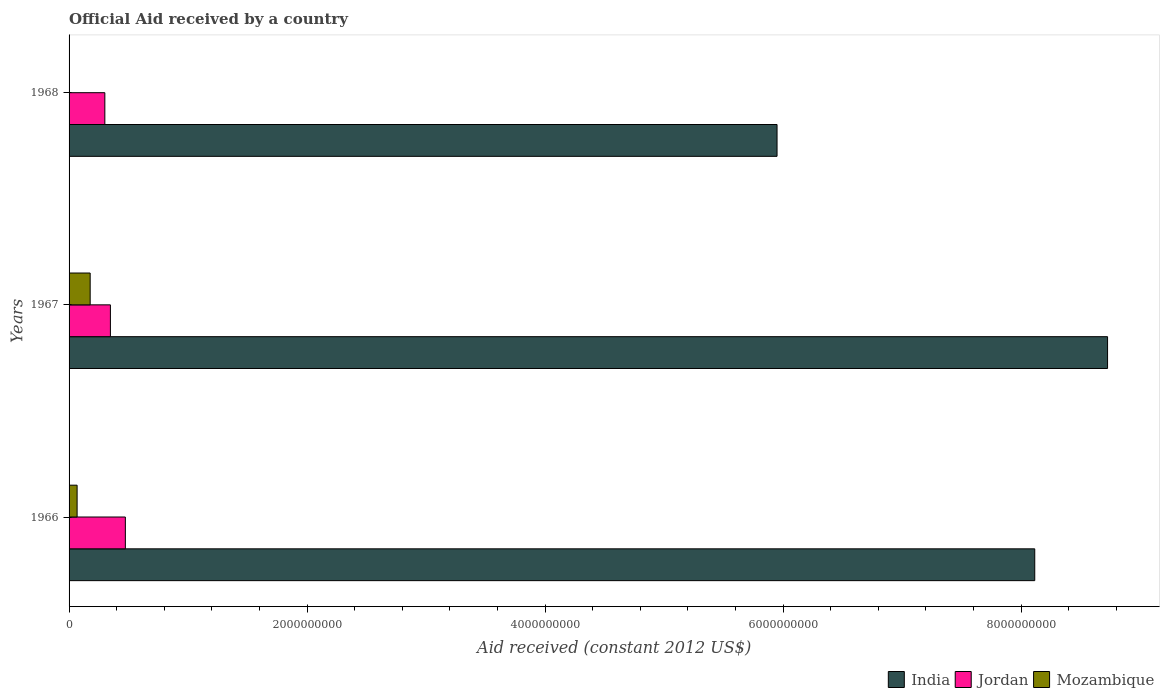What is the label of the 1st group of bars from the top?
Offer a terse response. 1968. What is the net official aid received in India in 1967?
Provide a short and direct response. 8.73e+09. Across all years, what is the maximum net official aid received in India?
Give a very brief answer. 8.73e+09. Across all years, what is the minimum net official aid received in India?
Provide a succinct answer. 5.95e+09. In which year was the net official aid received in India maximum?
Give a very brief answer. 1967. In which year was the net official aid received in Jordan minimum?
Make the answer very short. 1968. What is the total net official aid received in Mozambique in the graph?
Provide a succinct answer. 2.45e+08. What is the difference between the net official aid received in Jordan in 1967 and that in 1968?
Your response must be concise. 4.67e+07. What is the difference between the net official aid received in India in 1967 and the net official aid received in Mozambique in 1968?
Offer a terse response. 8.73e+09. What is the average net official aid received in India per year?
Ensure brevity in your answer.  7.60e+09. In the year 1966, what is the difference between the net official aid received in India and net official aid received in Mozambique?
Provide a succinct answer. 8.05e+09. In how many years, is the net official aid received in Jordan greater than 7200000000 US$?
Your answer should be very brief. 0. What is the ratio of the net official aid received in Mozambique in 1966 to that in 1968?
Your answer should be compact. 375. Is the difference between the net official aid received in India in 1966 and 1968 greater than the difference between the net official aid received in Mozambique in 1966 and 1968?
Your answer should be very brief. Yes. What is the difference between the highest and the second highest net official aid received in Mozambique?
Your response must be concise. 1.10e+08. What is the difference between the highest and the lowest net official aid received in Mozambique?
Keep it short and to the point. 1.77e+08. In how many years, is the net official aid received in Mozambique greater than the average net official aid received in Mozambique taken over all years?
Your answer should be compact. 1. What does the 3rd bar from the top in 1967 represents?
Your answer should be very brief. India. What does the 3rd bar from the bottom in 1966 represents?
Provide a short and direct response. Mozambique. Is it the case that in every year, the sum of the net official aid received in Mozambique and net official aid received in Jordan is greater than the net official aid received in India?
Your response must be concise. No. How many bars are there?
Make the answer very short. 9. Are all the bars in the graph horizontal?
Ensure brevity in your answer.  Yes. How many years are there in the graph?
Make the answer very short. 3. Are the values on the major ticks of X-axis written in scientific E-notation?
Your answer should be very brief. No. Does the graph contain any zero values?
Offer a very short reply. No. Does the graph contain grids?
Make the answer very short. No. Where does the legend appear in the graph?
Offer a very short reply. Bottom right. What is the title of the graph?
Your response must be concise. Official Aid received by a country. Does "Brunei Darussalam" appear as one of the legend labels in the graph?
Offer a terse response. No. What is the label or title of the X-axis?
Provide a short and direct response. Aid received (constant 2012 US$). What is the label or title of the Y-axis?
Keep it short and to the point. Years. What is the Aid received (constant 2012 US$) of India in 1966?
Provide a succinct answer. 8.11e+09. What is the Aid received (constant 2012 US$) of Jordan in 1966?
Provide a succinct answer. 4.73e+08. What is the Aid received (constant 2012 US$) in Mozambique in 1966?
Your answer should be compact. 6.75e+07. What is the Aid received (constant 2012 US$) of India in 1967?
Keep it short and to the point. 8.73e+09. What is the Aid received (constant 2012 US$) of Jordan in 1967?
Your answer should be very brief. 3.47e+08. What is the Aid received (constant 2012 US$) of Mozambique in 1967?
Give a very brief answer. 1.77e+08. What is the Aid received (constant 2012 US$) in India in 1968?
Provide a succinct answer. 5.95e+09. What is the Aid received (constant 2012 US$) in Jordan in 1968?
Your answer should be compact. 3.01e+08. Across all years, what is the maximum Aid received (constant 2012 US$) of India?
Give a very brief answer. 8.73e+09. Across all years, what is the maximum Aid received (constant 2012 US$) of Jordan?
Offer a terse response. 4.73e+08. Across all years, what is the maximum Aid received (constant 2012 US$) in Mozambique?
Your answer should be compact. 1.77e+08. Across all years, what is the minimum Aid received (constant 2012 US$) of India?
Offer a very short reply. 5.95e+09. Across all years, what is the minimum Aid received (constant 2012 US$) of Jordan?
Your response must be concise. 3.01e+08. Across all years, what is the minimum Aid received (constant 2012 US$) in Mozambique?
Your answer should be compact. 1.80e+05. What is the total Aid received (constant 2012 US$) of India in the graph?
Offer a terse response. 2.28e+1. What is the total Aid received (constant 2012 US$) in Jordan in the graph?
Ensure brevity in your answer.  1.12e+09. What is the total Aid received (constant 2012 US$) of Mozambique in the graph?
Offer a terse response. 2.45e+08. What is the difference between the Aid received (constant 2012 US$) of India in 1966 and that in 1967?
Ensure brevity in your answer.  -6.12e+08. What is the difference between the Aid received (constant 2012 US$) in Jordan in 1966 and that in 1967?
Provide a short and direct response. 1.26e+08. What is the difference between the Aid received (constant 2012 US$) in Mozambique in 1966 and that in 1967?
Make the answer very short. -1.10e+08. What is the difference between the Aid received (constant 2012 US$) of India in 1966 and that in 1968?
Make the answer very short. 2.17e+09. What is the difference between the Aid received (constant 2012 US$) in Jordan in 1966 and that in 1968?
Provide a short and direct response. 1.72e+08. What is the difference between the Aid received (constant 2012 US$) of Mozambique in 1966 and that in 1968?
Ensure brevity in your answer.  6.73e+07. What is the difference between the Aid received (constant 2012 US$) of India in 1967 and that in 1968?
Your response must be concise. 2.78e+09. What is the difference between the Aid received (constant 2012 US$) of Jordan in 1967 and that in 1968?
Your answer should be very brief. 4.67e+07. What is the difference between the Aid received (constant 2012 US$) of Mozambique in 1967 and that in 1968?
Ensure brevity in your answer.  1.77e+08. What is the difference between the Aid received (constant 2012 US$) in India in 1966 and the Aid received (constant 2012 US$) in Jordan in 1967?
Provide a short and direct response. 7.77e+09. What is the difference between the Aid received (constant 2012 US$) of India in 1966 and the Aid received (constant 2012 US$) of Mozambique in 1967?
Provide a succinct answer. 7.94e+09. What is the difference between the Aid received (constant 2012 US$) of Jordan in 1966 and the Aid received (constant 2012 US$) of Mozambique in 1967?
Keep it short and to the point. 2.96e+08. What is the difference between the Aid received (constant 2012 US$) of India in 1966 and the Aid received (constant 2012 US$) of Jordan in 1968?
Offer a terse response. 7.81e+09. What is the difference between the Aid received (constant 2012 US$) of India in 1966 and the Aid received (constant 2012 US$) of Mozambique in 1968?
Offer a terse response. 8.11e+09. What is the difference between the Aid received (constant 2012 US$) in Jordan in 1966 and the Aid received (constant 2012 US$) in Mozambique in 1968?
Offer a very short reply. 4.73e+08. What is the difference between the Aid received (constant 2012 US$) of India in 1967 and the Aid received (constant 2012 US$) of Jordan in 1968?
Provide a succinct answer. 8.43e+09. What is the difference between the Aid received (constant 2012 US$) in India in 1967 and the Aid received (constant 2012 US$) in Mozambique in 1968?
Make the answer very short. 8.73e+09. What is the difference between the Aid received (constant 2012 US$) in Jordan in 1967 and the Aid received (constant 2012 US$) in Mozambique in 1968?
Ensure brevity in your answer.  3.47e+08. What is the average Aid received (constant 2012 US$) in India per year?
Give a very brief answer. 7.60e+09. What is the average Aid received (constant 2012 US$) in Jordan per year?
Offer a very short reply. 3.74e+08. What is the average Aid received (constant 2012 US$) of Mozambique per year?
Keep it short and to the point. 8.17e+07. In the year 1966, what is the difference between the Aid received (constant 2012 US$) of India and Aid received (constant 2012 US$) of Jordan?
Your response must be concise. 7.64e+09. In the year 1966, what is the difference between the Aid received (constant 2012 US$) of India and Aid received (constant 2012 US$) of Mozambique?
Offer a terse response. 8.05e+09. In the year 1966, what is the difference between the Aid received (constant 2012 US$) of Jordan and Aid received (constant 2012 US$) of Mozambique?
Ensure brevity in your answer.  4.05e+08. In the year 1967, what is the difference between the Aid received (constant 2012 US$) in India and Aid received (constant 2012 US$) in Jordan?
Keep it short and to the point. 8.38e+09. In the year 1967, what is the difference between the Aid received (constant 2012 US$) of India and Aid received (constant 2012 US$) of Mozambique?
Your response must be concise. 8.55e+09. In the year 1967, what is the difference between the Aid received (constant 2012 US$) of Jordan and Aid received (constant 2012 US$) of Mozambique?
Provide a short and direct response. 1.70e+08. In the year 1968, what is the difference between the Aid received (constant 2012 US$) of India and Aid received (constant 2012 US$) of Jordan?
Provide a succinct answer. 5.65e+09. In the year 1968, what is the difference between the Aid received (constant 2012 US$) of India and Aid received (constant 2012 US$) of Mozambique?
Provide a short and direct response. 5.95e+09. In the year 1968, what is the difference between the Aid received (constant 2012 US$) of Jordan and Aid received (constant 2012 US$) of Mozambique?
Ensure brevity in your answer.  3.00e+08. What is the ratio of the Aid received (constant 2012 US$) of India in 1966 to that in 1967?
Offer a very short reply. 0.93. What is the ratio of the Aid received (constant 2012 US$) in Jordan in 1966 to that in 1967?
Give a very brief answer. 1.36. What is the ratio of the Aid received (constant 2012 US$) in Mozambique in 1966 to that in 1967?
Your answer should be very brief. 0.38. What is the ratio of the Aid received (constant 2012 US$) in India in 1966 to that in 1968?
Give a very brief answer. 1.36. What is the ratio of the Aid received (constant 2012 US$) in Jordan in 1966 to that in 1968?
Provide a succinct answer. 1.57. What is the ratio of the Aid received (constant 2012 US$) of Mozambique in 1966 to that in 1968?
Make the answer very short. 375. What is the ratio of the Aid received (constant 2012 US$) in India in 1967 to that in 1968?
Give a very brief answer. 1.47. What is the ratio of the Aid received (constant 2012 US$) of Jordan in 1967 to that in 1968?
Your response must be concise. 1.16. What is the ratio of the Aid received (constant 2012 US$) of Mozambique in 1967 to that in 1968?
Provide a short and direct response. 985. What is the difference between the highest and the second highest Aid received (constant 2012 US$) of India?
Offer a very short reply. 6.12e+08. What is the difference between the highest and the second highest Aid received (constant 2012 US$) of Jordan?
Offer a terse response. 1.26e+08. What is the difference between the highest and the second highest Aid received (constant 2012 US$) of Mozambique?
Your answer should be very brief. 1.10e+08. What is the difference between the highest and the lowest Aid received (constant 2012 US$) of India?
Your answer should be compact. 2.78e+09. What is the difference between the highest and the lowest Aid received (constant 2012 US$) in Jordan?
Make the answer very short. 1.72e+08. What is the difference between the highest and the lowest Aid received (constant 2012 US$) of Mozambique?
Provide a succinct answer. 1.77e+08. 